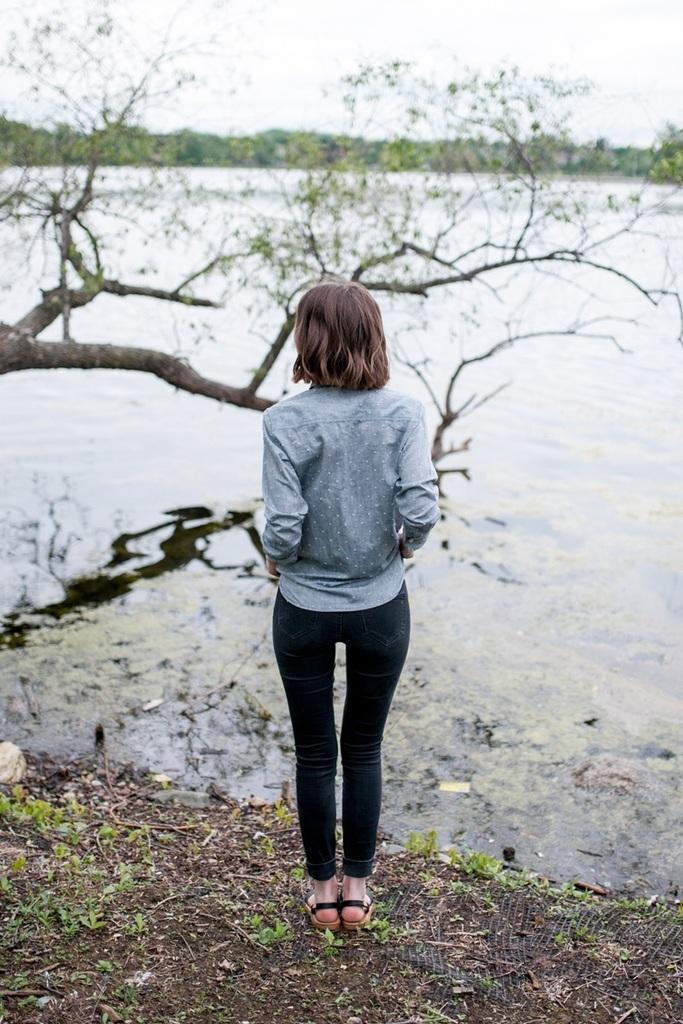How would you summarize this image in a sentence or two? In the center of the image we can see a lady standing. In the background there is water and we can see trees. At the top there is sky. 